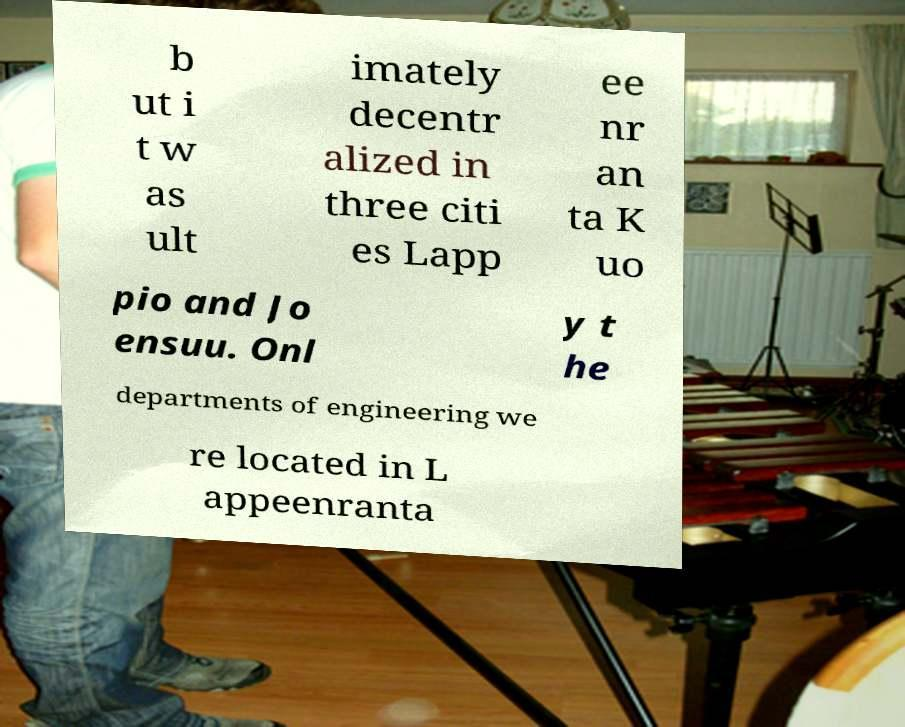What messages or text are displayed in this image? I need them in a readable, typed format. b ut i t w as ult imately decentr alized in three citi es Lapp ee nr an ta K uo pio and Jo ensuu. Onl y t he departments of engineering we re located in L appeenranta 